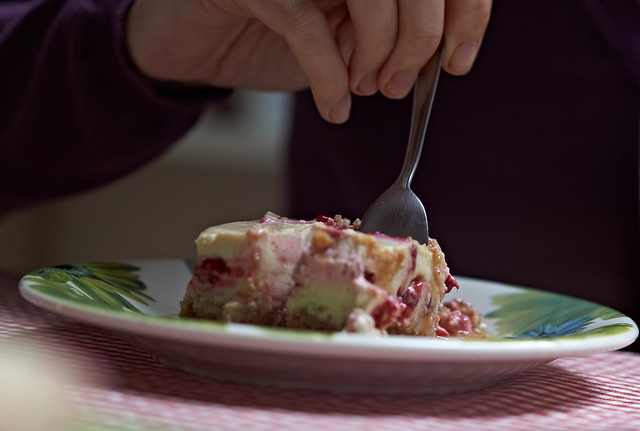<image>What flavor is the frosting? It is unclear what the flavor of the frosting is. It could be raspberry, strawberry, vanilla, white cream or there is no frosting. What flavor ice cream is in the bowl? I don't know what flavor the ice cream in the bowl is. It can be strawberry or vanilla. What flavor is the frosting? I am not sure what flavor the frosting is. It can be raspberry, white, strawberry or vanilla. What flavor ice cream is in the bowl? I am not sure what flavor ice cream is in the bowl. It can be strawberry, strawberry shortcake, vanilla, or fruit. 